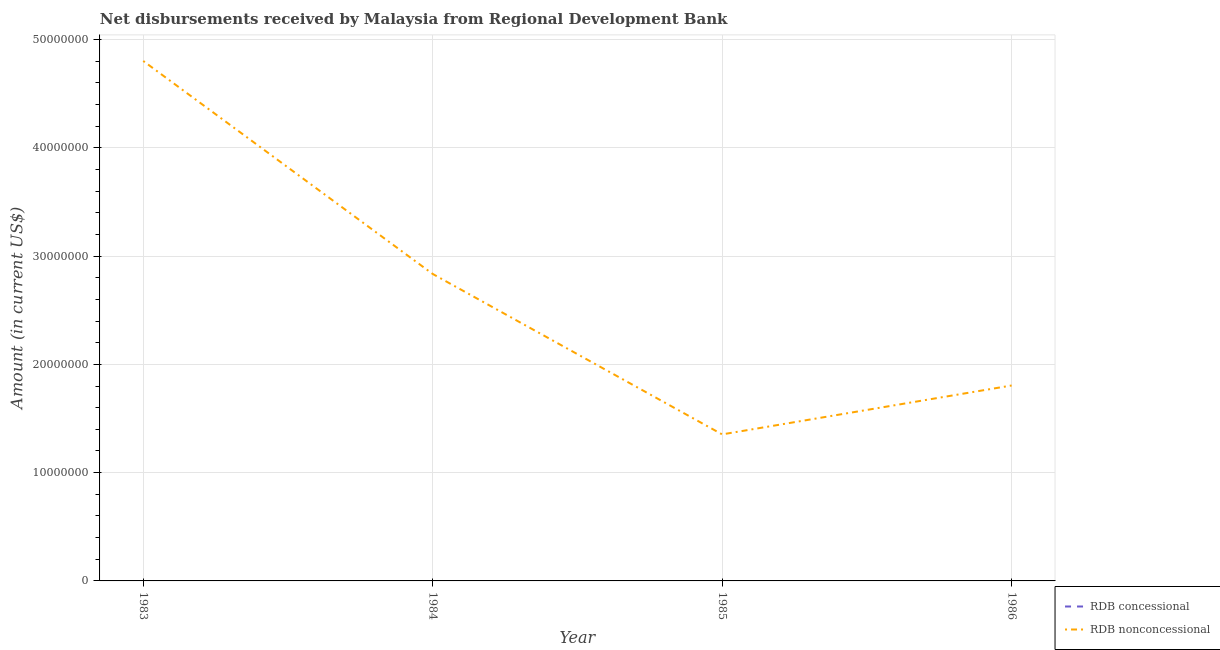Is the number of lines equal to the number of legend labels?
Ensure brevity in your answer.  No. Across all years, what is the maximum net non concessional disbursements from rdb?
Offer a very short reply. 4.80e+07. Across all years, what is the minimum net non concessional disbursements from rdb?
Keep it short and to the point. 1.35e+07. In which year was the net non concessional disbursements from rdb maximum?
Your answer should be compact. 1983. What is the total net non concessional disbursements from rdb in the graph?
Ensure brevity in your answer.  1.08e+08. What is the difference between the net non concessional disbursements from rdb in 1983 and that in 1984?
Your answer should be very brief. 1.97e+07. What is the difference between the net concessional disbursements from rdb in 1983 and the net non concessional disbursements from rdb in 1985?
Your response must be concise. -1.35e+07. What is the average net concessional disbursements from rdb per year?
Offer a terse response. 0. In how many years, is the net non concessional disbursements from rdb greater than 4000000 US$?
Make the answer very short. 4. What is the ratio of the net non concessional disbursements from rdb in 1983 to that in 1984?
Provide a succinct answer. 1.69. Is the net non concessional disbursements from rdb in 1984 less than that in 1985?
Make the answer very short. No. What is the difference between the highest and the second highest net non concessional disbursements from rdb?
Give a very brief answer. 1.97e+07. What is the difference between the highest and the lowest net non concessional disbursements from rdb?
Your answer should be compact. 3.45e+07. Does the net non concessional disbursements from rdb monotonically increase over the years?
Make the answer very short. No. Is the net non concessional disbursements from rdb strictly less than the net concessional disbursements from rdb over the years?
Ensure brevity in your answer.  No. Does the graph contain any zero values?
Your answer should be very brief. Yes. Does the graph contain grids?
Ensure brevity in your answer.  Yes. Where does the legend appear in the graph?
Offer a very short reply. Bottom right. How many legend labels are there?
Give a very brief answer. 2. What is the title of the graph?
Your answer should be very brief. Net disbursements received by Malaysia from Regional Development Bank. What is the label or title of the X-axis?
Your answer should be compact. Year. What is the Amount (in current US$) of RDB concessional in 1983?
Provide a short and direct response. 0. What is the Amount (in current US$) in RDB nonconcessional in 1983?
Your answer should be very brief. 4.80e+07. What is the Amount (in current US$) in RDB concessional in 1984?
Give a very brief answer. 0. What is the Amount (in current US$) in RDB nonconcessional in 1984?
Offer a very short reply. 2.83e+07. What is the Amount (in current US$) of RDB nonconcessional in 1985?
Offer a very short reply. 1.35e+07. What is the Amount (in current US$) in RDB nonconcessional in 1986?
Your answer should be very brief. 1.80e+07. Across all years, what is the maximum Amount (in current US$) in RDB nonconcessional?
Provide a short and direct response. 4.80e+07. Across all years, what is the minimum Amount (in current US$) in RDB nonconcessional?
Offer a very short reply. 1.35e+07. What is the total Amount (in current US$) of RDB nonconcessional in the graph?
Provide a succinct answer. 1.08e+08. What is the difference between the Amount (in current US$) in RDB nonconcessional in 1983 and that in 1984?
Your response must be concise. 1.97e+07. What is the difference between the Amount (in current US$) in RDB nonconcessional in 1983 and that in 1985?
Ensure brevity in your answer.  3.45e+07. What is the difference between the Amount (in current US$) in RDB nonconcessional in 1983 and that in 1986?
Your answer should be compact. 3.00e+07. What is the difference between the Amount (in current US$) of RDB nonconcessional in 1984 and that in 1985?
Make the answer very short. 1.48e+07. What is the difference between the Amount (in current US$) in RDB nonconcessional in 1984 and that in 1986?
Provide a succinct answer. 1.03e+07. What is the difference between the Amount (in current US$) of RDB nonconcessional in 1985 and that in 1986?
Offer a terse response. -4.52e+06. What is the average Amount (in current US$) of RDB nonconcessional per year?
Make the answer very short. 2.70e+07. What is the ratio of the Amount (in current US$) in RDB nonconcessional in 1983 to that in 1984?
Keep it short and to the point. 1.69. What is the ratio of the Amount (in current US$) of RDB nonconcessional in 1983 to that in 1985?
Provide a short and direct response. 3.55. What is the ratio of the Amount (in current US$) in RDB nonconcessional in 1983 to that in 1986?
Offer a terse response. 2.66. What is the ratio of the Amount (in current US$) in RDB nonconcessional in 1984 to that in 1985?
Your answer should be very brief. 2.09. What is the ratio of the Amount (in current US$) of RDB nonconcessional in 1984 to that in 1986?
Give a very brief answer. 1.57. What is the ratio of the Amount (in current US$) in RDB nonconcessional in 1985 to that in 1986?
Provide a succinct answer. 0.75. What is the difference between the highest and the second highest Amount (in current US$) in RDB nonconcessional?
Your response must be concise. 1.97e+07. What is the difference between the highest and the lowest Amount (in current US$) in RDB nonconcessional?
Your answer should be very brief. 3.45e+07. 